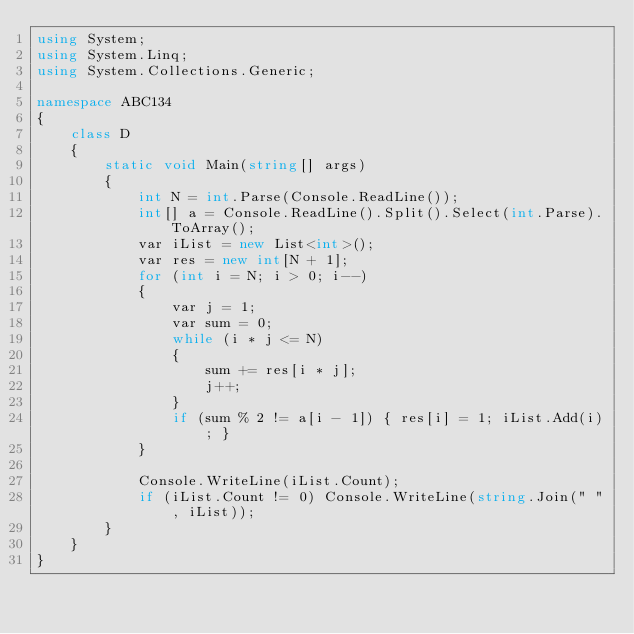Convert code to text. <code><loc_0><loc_0><loc_500><loc_500><_C#_>using System;
using System.Linq;
using System.Collections.Generic;

namespace ABC134
{
    class D
    {
        static void Main(string[] args)
        {
            int N = int.Parse(Console.ReadLine());
            int[] a = Console.ReadLine().Split().Select(int.Parse).ToArray();
            var iList = new List<int>();
            var res = new int[N + 1];
            for (int i = N; i > 0; i--)
            {
                var j = 1;
                var sum = 0;
                while (i * j <= N)
                {
                    sum += res[i * j];
                    j++;
                }
                if (sum % 2 != a[i - 1]) { res[i] = 1; iList.Add(i); }
            }

            Console.WriteLine(iList.Count);
            if (iList.Count != 0) Console.WriteLine(string.Join(" ", iList));
        }
    }
}</code> 